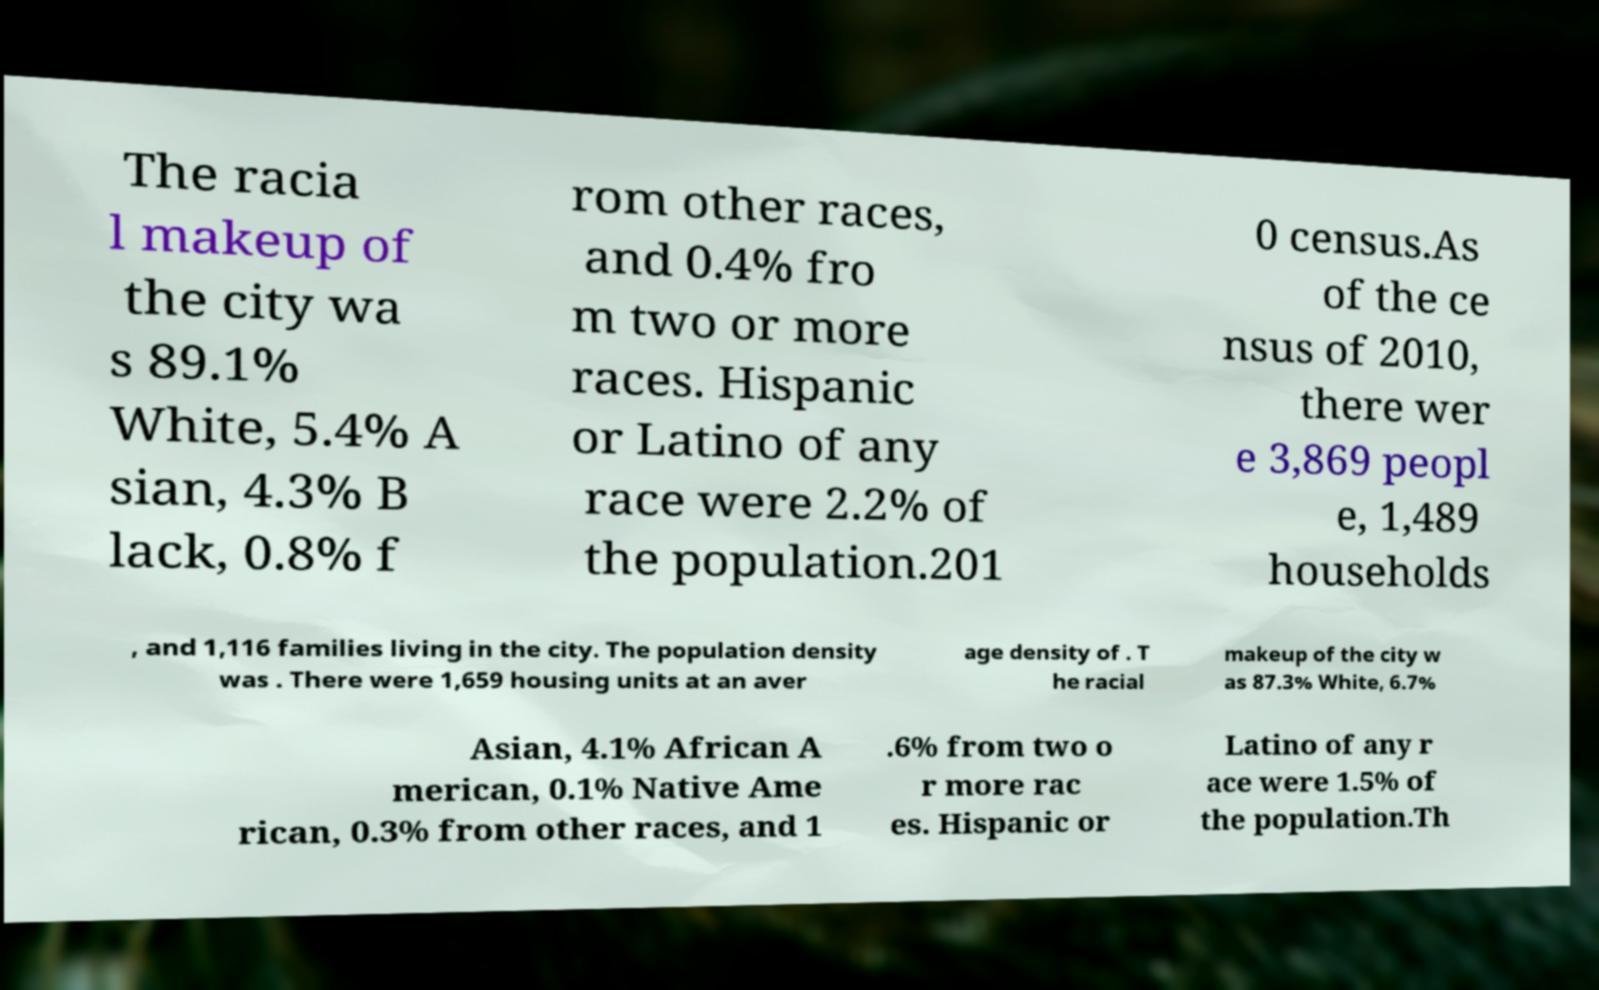Please read and relay the text visible in this image. What does it say? The racia l makeup of the city wa s 89.1% White, 5.4% A sian, 4.3% B lack, 0.8% f rom other races, and 0.4% fro m two or more races. Hispanic or Latino of any race were 2.2% of the population.201 0 census.As of the ce nsus of 2010, there wer e 3,869 peopl e, 1,489 households , and 1,116 families living in the city. The population density was . There were 1,659 housing units at an aver age density of . T he racial makeup of the city w as 87.3% White, 6.7% Asian, 4.1% African A merican, 0.1% Native Ame rican, 0.3% from other races, and 1 .6% from two o r more rac es. Hispanic or Latino of any r ace were 1.5% of the population.Th 